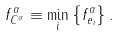Convert formula to latex. <formula><loc_0><loc_0><loc_500><loc_500>f _ { C ^ { \alpha } } ^ { \alpha } \equiv \min _ { i } \left \{ f _ { e _ { i } } ^ { \alpha } \right \} .</formula> 